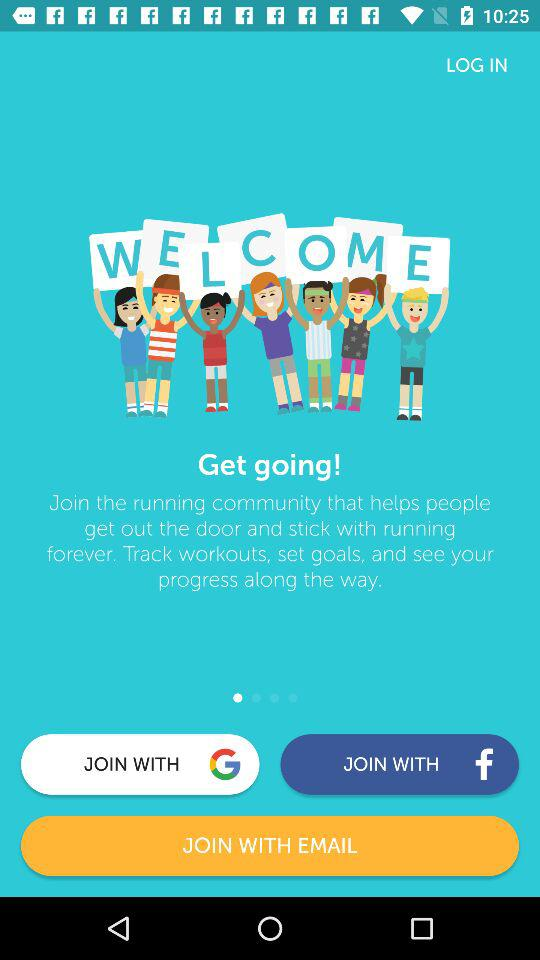With which accounts can the user join? The user can join with "Google", "Facebook" and "EMAIL". 